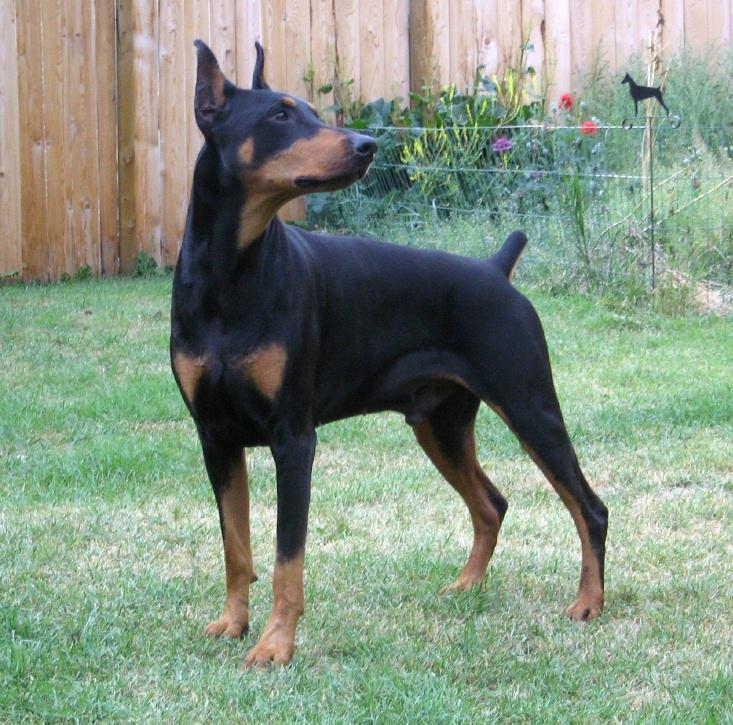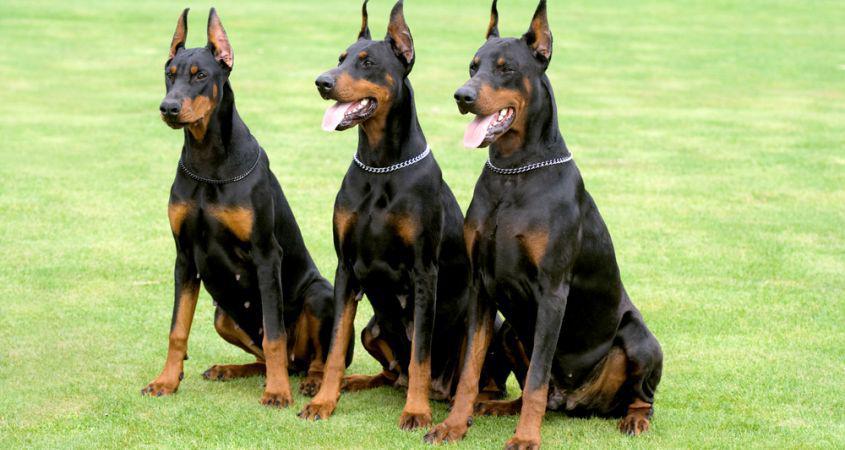The first image is the image on the left, the second image is the image on the right. Considering the images on both sides, is "One dog is reclining." valid? Answer yes or no. No. The first image is the image on the left, the second image is the image on the right. Evaluate the accuracy of this statement regarding the images: "One image shows one pointy-eared doberman in a collar reclining on green ground, and the other image shows one leftward-facing doberman with a closed mouth and pointy ears.". Is it true? Answer yes or no. No. 